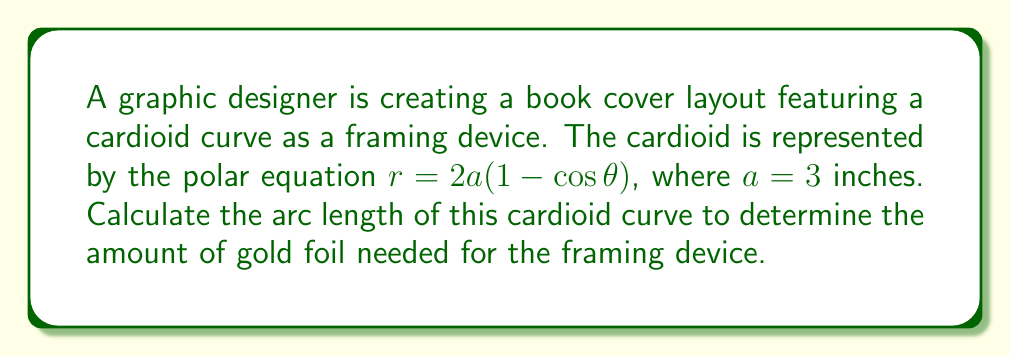Help me with this question. To find the arc length of the cardioid curve, we'll follow these steps:

1) The general formula for the arc length of a polar curve is:

   $$L = \int_0^{2\pi} \sqrt{r^2 + \left(\frac{dr}{d\theta}\right)^2} d\theta$$

2) For our cardioid, $r = 2a(1 - \cos\theta)$ where $a = 3$ inches. Let's first find $\frac{dr}{d\theta}$:

   $$\frac{dr}{d\theta} = 2a\sin\theta$$

3) Now, let's substitute these into our arc length formula:

   $$L = \int_0^{2\pi} \sqrt{(2a(1-\cos\theta))^2 + (2a\sin\theta)^2} d\theta$$

4) Simplify the expression under the square root:

   $$\begin{align*}
   (2a(1-\cos\theta))^2 + (2a\sin\theta)^2 &= 4a^2(1-2\cos\theta+\cos^2\theta) + 4a^2\sin^2\theta \\
   &= 4a^2(1-2\cos\theta+\cos^2\theta+\sin^2\theta) \\
   &= 4a^2(2-2\cos\theta) \\
   &= 8a^2(1-\cos\theta)
   \end{align*}$$

5) Our integral now becomes:

   $$L = \int_0^{2\pi} \sqrt{8a^2(1-\cos\theta)} d\theta = 2a\sqrt{2} \int_0^{2\pi} \sqrt{1-\cos\theta} d\theta$$

6) This integral can be solved using the substitution $u = \tan(\frac{\theta}{2})$. After substitution and simplification, we get:

   $$L = 8a$$

7) Substituting $a = 3$ inches:

   $$L = 8 * 3 = 24 \text{ inches}$$
Answer: The arc length of the cardioid curve is 24 inches. 